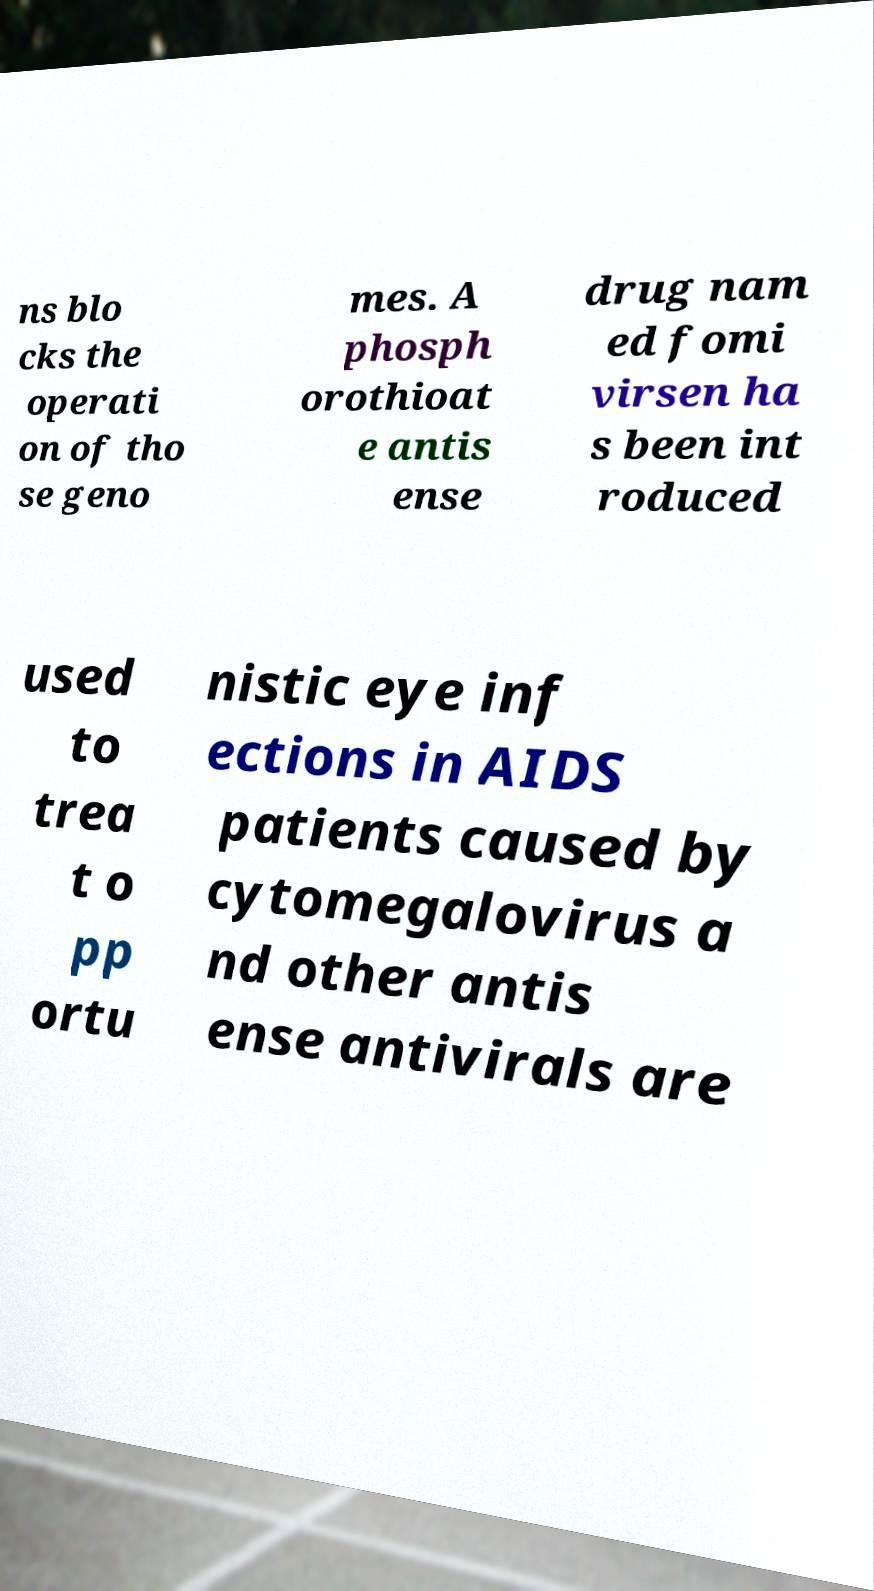What messages or text are displayed in this image? I need them in a readable, typed format. ns blo cks the operati on of tho se geno mes. A phosph orothioat e antis ense drug nam ed fomi virsen ha s been int roduced used to trea t o pp ortu nistic eye inf ections in AIDS patients caused by cytomegalovirus a nd other antis ense antivirals are 